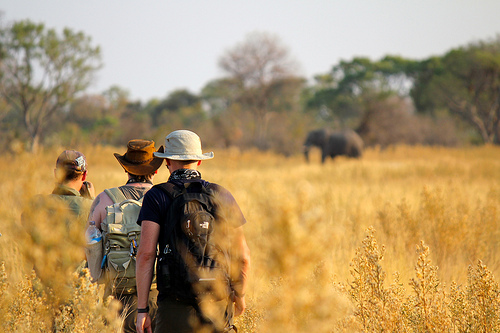Does the backpack that is to the right of the men have large size and red color? No, the backpack does not have a large size and red color. 